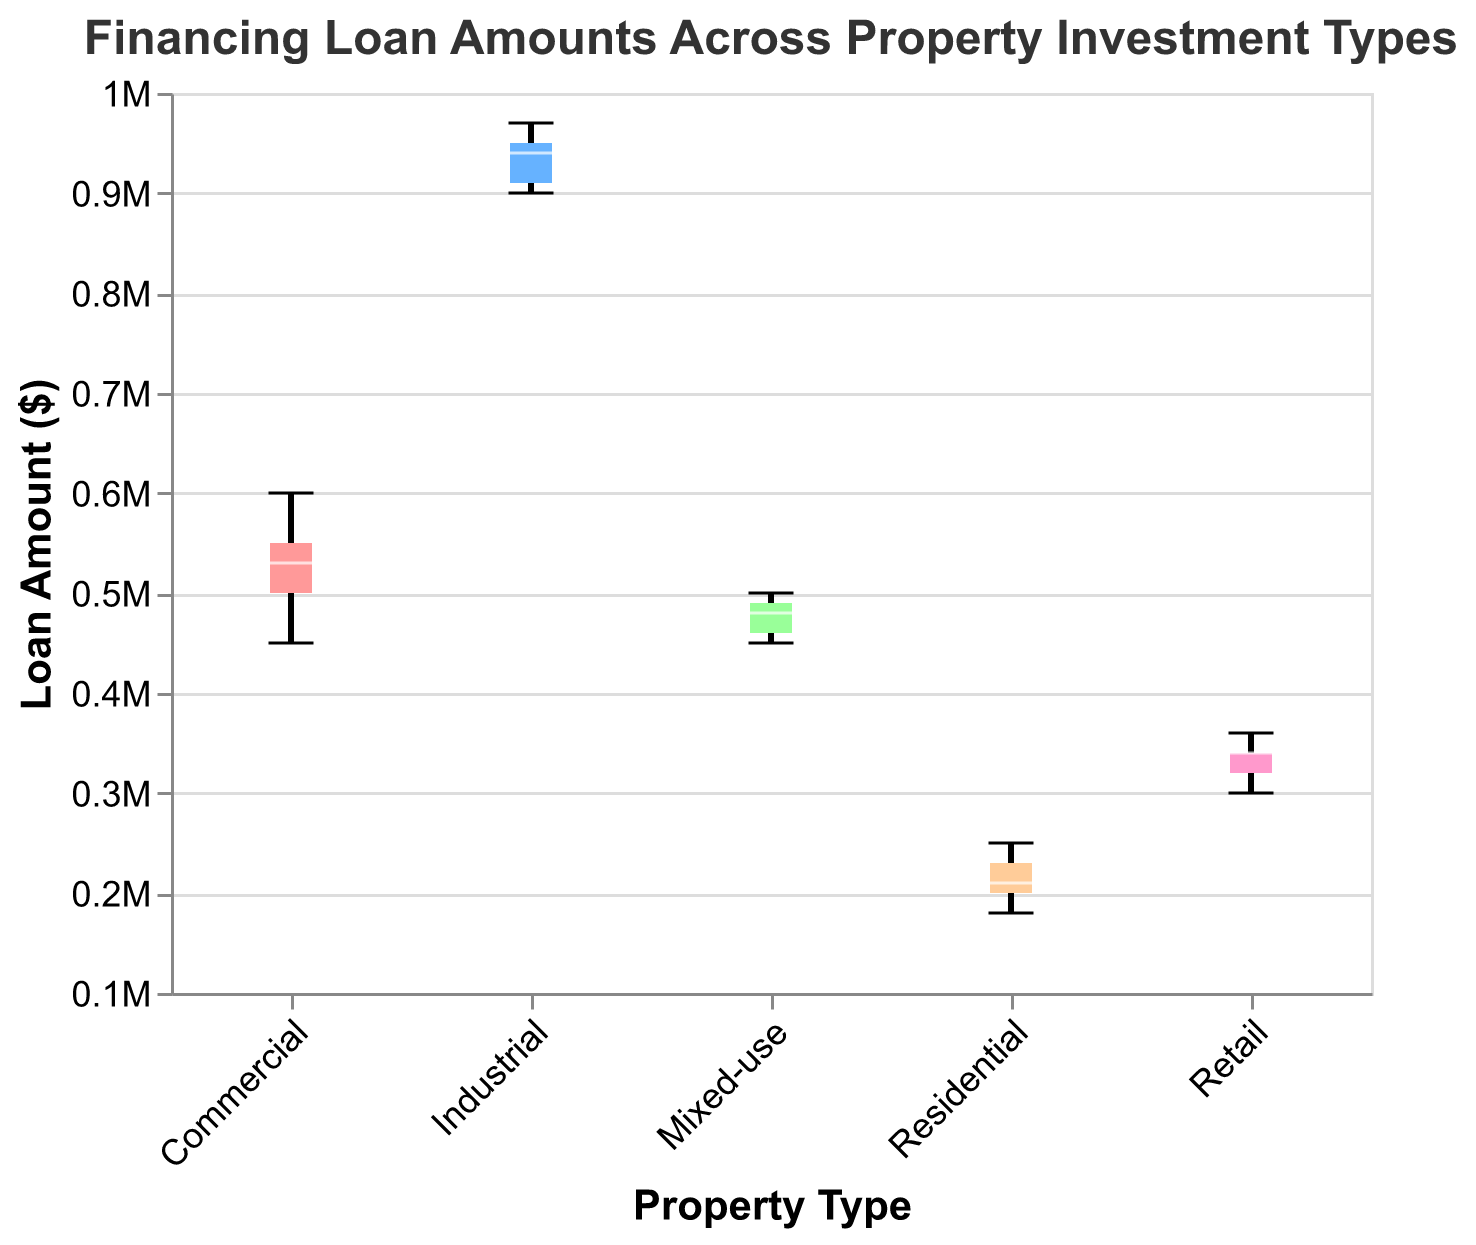What's the median loan amount for Industrial properties? To find the median loan amount for Industrial properties, look at the median line within the Industrial box plot, which is represented typically by a line inside the box.
Answer: $940,000 Which property type has the widest range of loan amounts? To determine the property type with the widest range of loan amounts, look at the range between the minimum and maximum whiskers in each box plot and compare them.
Answer: Industrial What's the interquartile range (IQR) for Commercial properties? The interquartile range (IQR) is the difference between the upper quartile (Q3) and the lower quartile (Q1), which are the top and bottom edges of the box in a box plot. For Commercial properties, read the Q1 and Q3 values from the box edges and subtract them.
Answer: $100,000 How do the loan amounts for Residential and Retail properties compare? Compare the median lines and the spread of the box plots for Residential and Retail properties. Residential properties have a median of around $210,000 to $230,000, whereas Retail properties have a median of around $320,000 to $340,000. Look at the boxes' spans to understand the spread.
Answer: Retail properties have higher loan amounts What does the notch in the box plots indicate? In notched box plots, the notch represents the 95% confidence interval of the median. If the notches of two boxes do not overlap, it indicates a statistically significant difference between the medians.
Answer: 95% confidence interval of the median Which property type has the smallest interquartile range (IQR) for loan amounts? The smallest interquartile range (IQR) is noted by the shortest height of the box in the box plots. Identify which box is the shortest in height.
Answer: Retail Is there an overlap in the 95% confidence intervals for the median loan amounts between Commercial and Mixed-use properties? Check the notches in the box plots for Commercial and Mixed-use properties. If the notches overlap, the 95% confidence intervals indicate no statistically significant difference between the medians.
Answer: Yes What is the maximum loan amount for Residential properties? The maximum loan amount for Residential properties is indicated by the top whisker of the Residential box plot.
Answer: $250,000 Which property type has the highest median loan amount? Identify the box plot with the highest median line, which is typically the line inside the box.
Answer: Industrial Are the loan amounts for Mixed-use properties more similar to Commercial or Residential properties? Compare the medians and spreads (IQRs and ranges) of the box plots. Mixed-use properties will be more similar to the type whose median and spread are closer.
Answer: Commercial 